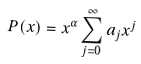<formula> <loc_0><loc_0><loc_500><loc_500>P ( x ) = x ^ { \alpha } \sum _ { j = 0 } ^ { \infty } a _ { j } x ^ { j }</formula> 